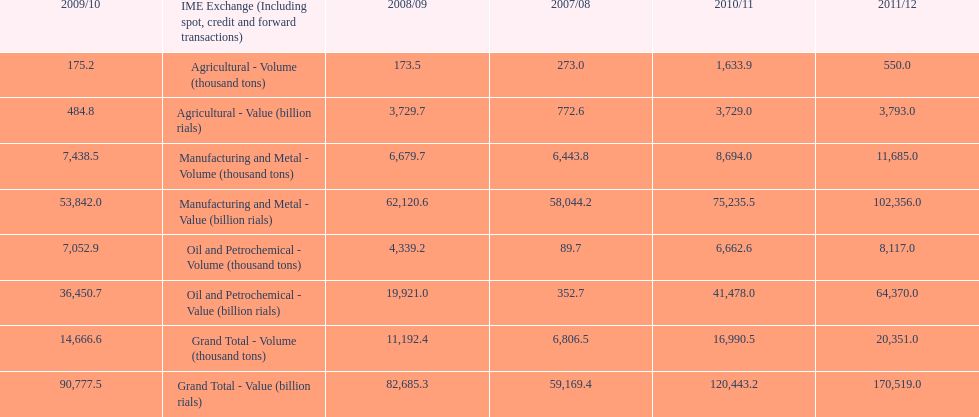In how many years was the value of agriculture, in billion rials, greater than 500 in iran? 4. 